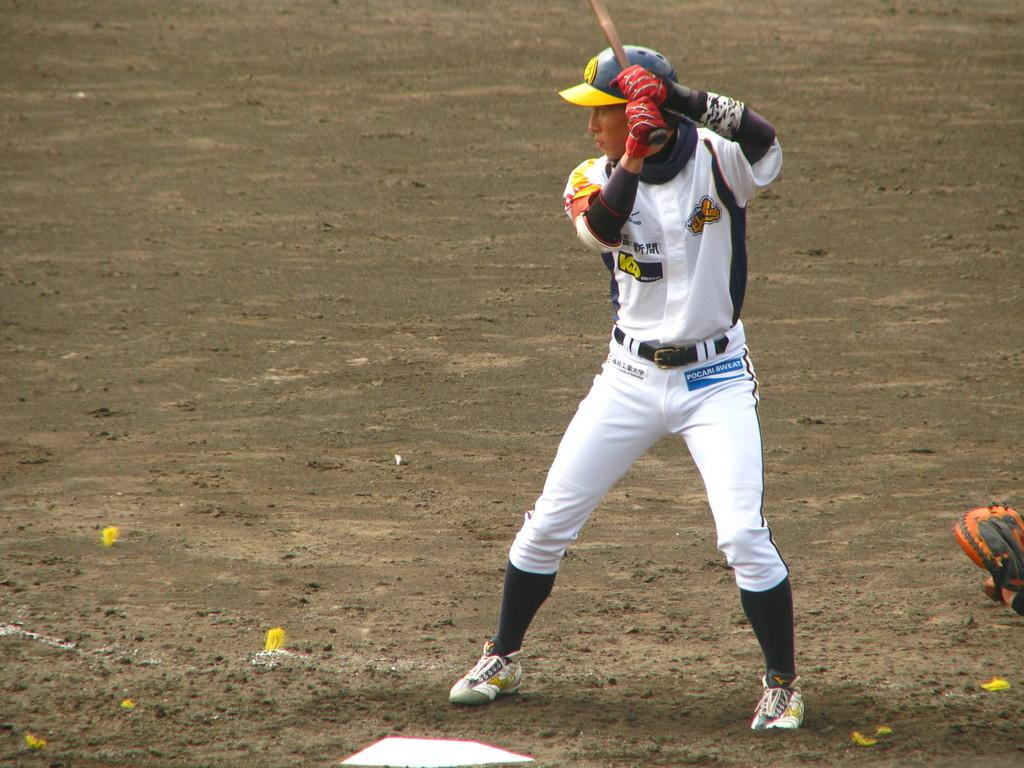What can be seen in the image? There is a person in the image. What direction is the person facing? The person is standing facing towards the left. What is the person wearing on their head? The person is wearing a cap. What type of footwear is the person wearing? The person is wearing shoes. What is the person holding in their hands? The person is holding a stick. What type of surface is visible in the image? There is ground visible in the image. What objects can be seen on the ground? There are objects on the ground. What type of wool is being used to create friction between the person's shoes and the ground? There is no mention of wool or friction between the person's shoes and the ground in the image. 